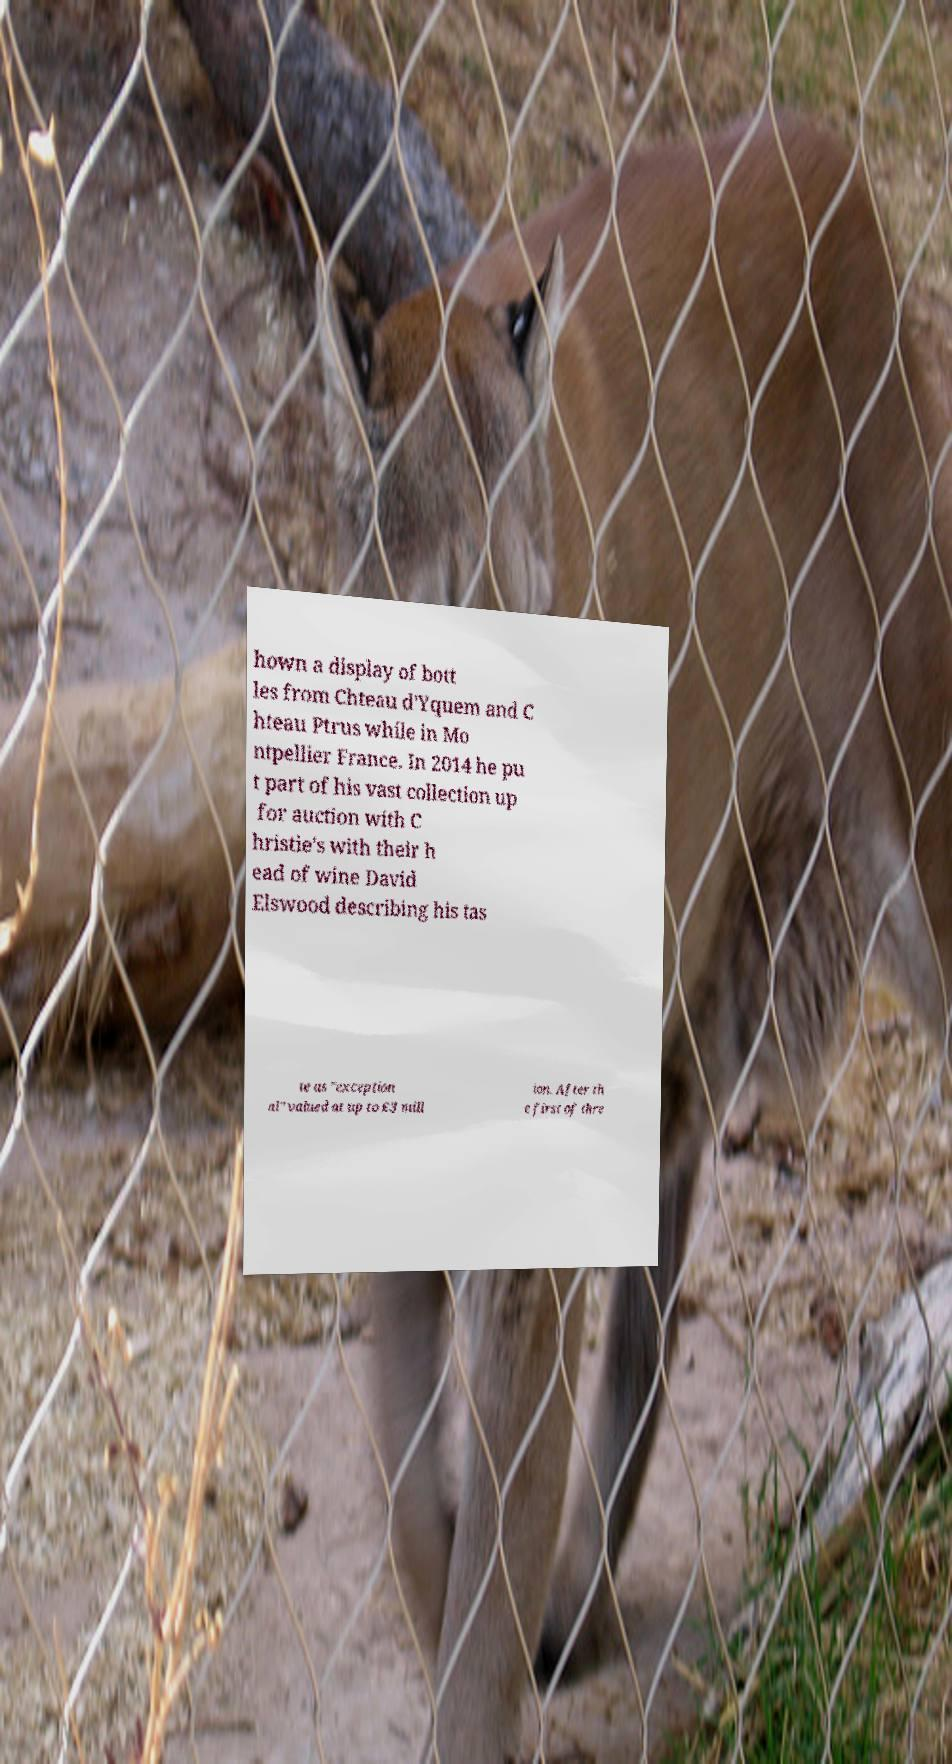What messages or text are displayed in this image? I need them in a readable, typed format. hown a display of bott les from Chteau d'Yquem and C hteau Ptrus while in Mo ntpellier France. In 2014 he pu t part of his vast collection up for auction with C hristie's with their h ead of wine David Elswood describing his tas te as "exception al" valued at up to £3 mill ion. After th e first of thre 